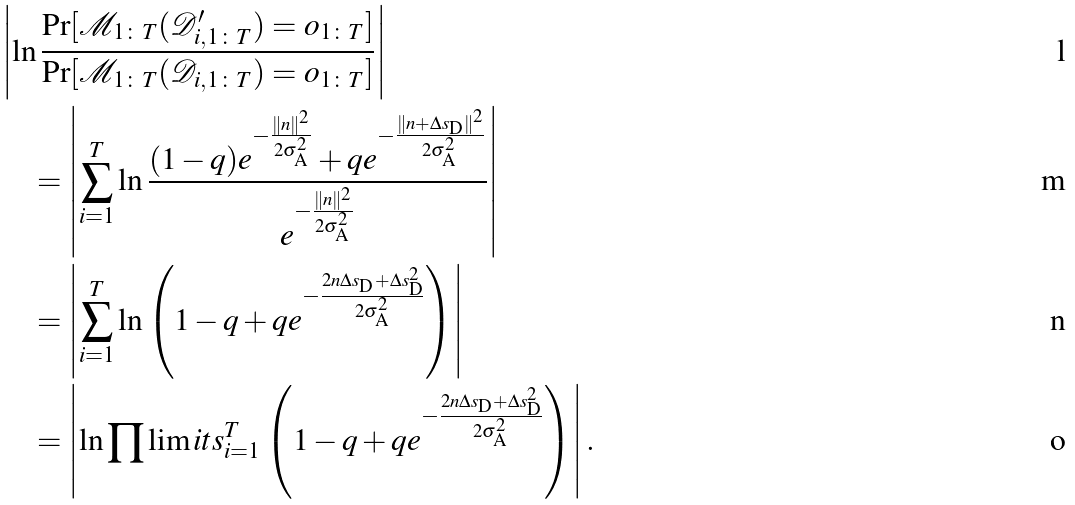<formula> <loc_0><loc_0><loc_500><loc_500>& \left | \ln \frac { \Pr [ \mathcal { M } _ { 1 \colon T } ( \mathcal { D } ^ { \prime } _ { i , 1 \colon T } ) = o _ { 1 \colon T } ] } { \Pr [ \mathcal { M } _ { 1 \colon T } ( \mathcal { D } _ { i , 1 \colon T } ) = o _ { 1 \colon T } ] } \right | \\ & \quad = \left | \sum _ { i = 1 } ^ { T } { \ln \frac { ( 1 - q ) e ^ { - \frac { \| n \| ^ { 2 } } { 2 \sigma _ { \text {A} } ^ { 2 } } } + q e ^ { - \frac { \| n + \Delta s _ { \text {D} } \| ^ { 2 } } { 2 \sigma _ { \text {A} } ^ { 2 } } } } { e ^ { - \frac { \| n \| ^ { 2 } } { 2 \sigma _ { \text {A} } ^ { 2 } } } } } \right | \\ & \quad = \left | \sum _ { i = 1 } ^ { T } { \ln \left ( 1 - q + q e ^ { - \frac { 2 n \Delta s _ { \text {D} } + \Delta s _ { \text {D} } ^ { 2 } } { 2 \sigma _ { \text {A} } ^ { 2 } } } \right ) } \right | \\ & \quad = \left | { \ln \prod \lim i t s _ { i = 1 } ^ { T } \left ( 1 - q + q e ^ { - \frac { 2 n \Delta s _ { \text {D} } + \Delta s _ { \text {D} } ^ { 2 } } { 2 \sigma _ { \text {A} } ^ { 2 } } } \right ) } \right | .</formula> 